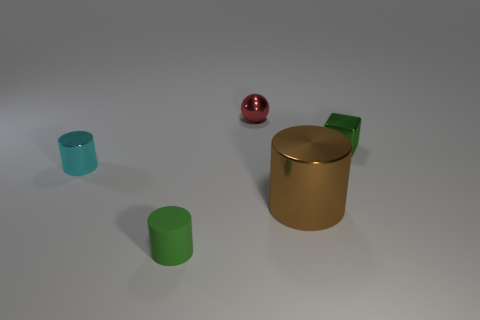Add 1 small green matte cylinders. How many objects exist? 6 Subtract all cubes. How many objects are left? 4 Add 5 small cylinders. How many small cylinders are left? 7 Add 1 yellow spheres. How many yellow spheres exist? 1 Subtract 1 brown cylinders. How many objects are left? 4 Subtract all cyan cylinders. Subtract all large brown metallic objects. How many objects are left? 3 